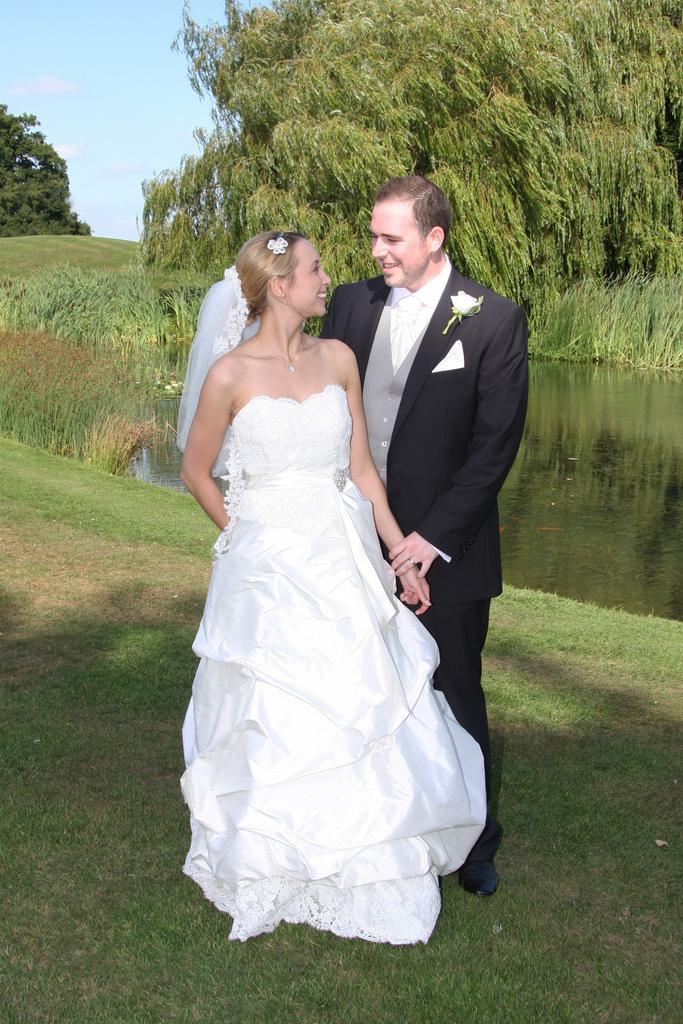How many people are in the image? There are two persons standing in the center of the image. What is at the bottom of the image? There is grass at the bottom of the image. What can be seen in the image besides the people? There is water visible in the image. What is visible in the background of the image? There are trees in the background of the image. Where is the squirrel performing on the stage in the image? There is no squirrel or stage present in the image. 